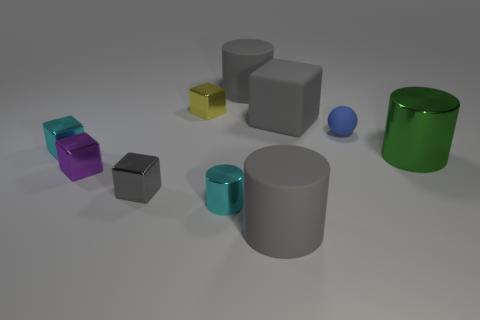What is the material of the other block that is the same color as the rubber block?
Your answer should be very brief. Metal. The big metal thing is what shape?
Keep it short and to the point. Cylinder. How many other things are there of the same material as the small blue ball?
Ensure brevity in your answer.  3. There is another shiny thing that is the same shape as the large green metallic thing; what size is it?
Give a very brief answer. Small. The tiny yellow block left of the gray thing that is right of the gray cylinder that is in front of the small shiny cylinder is made of what material?
Make the answer very short. Metal. Are any tiny blue blocks visible?
Provide a succinct answer. No. There is a rubber sphere; does it have the same color as the rubber cylinder in front of the cyan metallic cube?
Give a very brief answer. No. The tiny ball has what color?
Give a very brief answer. Blue. Is there any other thing that is the same shape as the small blue matte object?
Provide a short and direct response. No. What color is the rubber object that is the same shape as the yellow metal thing?
Offer a very short reply. Gray. 